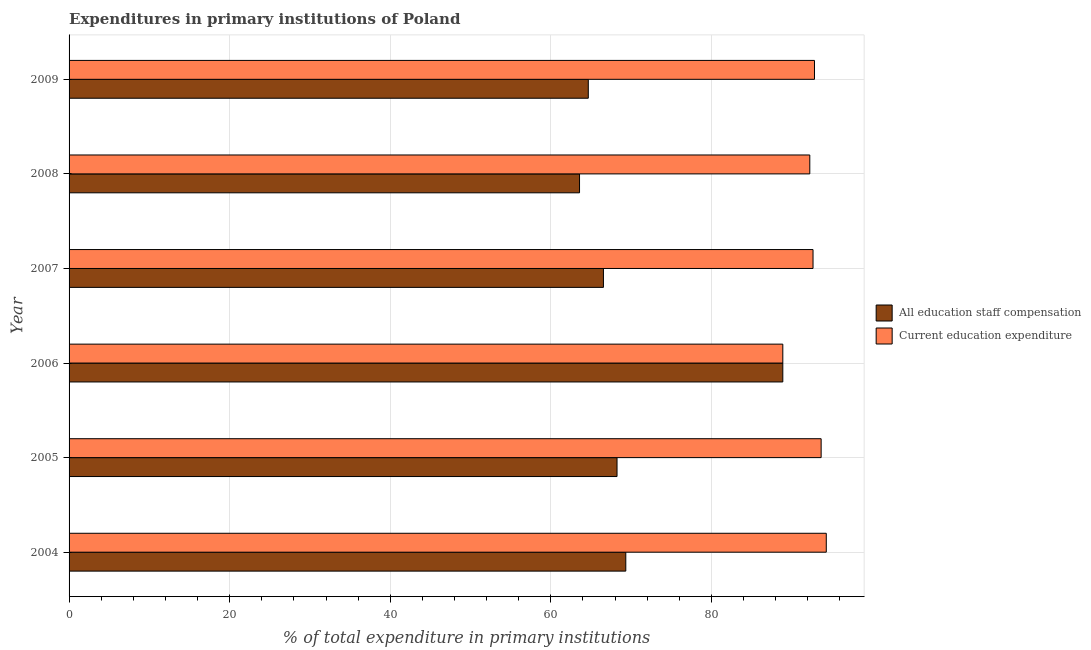How many groups of bars are there?
Ensure brevity in your answer.  6. How many bars are there on the 5th tick from the top?
Offer a terse response. 2. What is the expenditure in education in 2008?
Your answer should be very brief. 92.25. Across all years, what is the maximum expenditure in staff compensation?
Your response must be concise. 88.89. Across all years, what is the minimum expenditure in education?
Keep it short and to the point. 88.89. In which year was the expenditure in education maximum?
Provide a succinct answer. 2004. What is the total expenditure in education in the graph?
Provide a succinct answer. 554.62. What is the difference between the expenditure in education in 2007 and that in 2009?
Keep it short and to the point. -0.18. What is the difference between the expenditure in education in 2008 and the expenditure in staff compensation in 2007?
Offer a terse response. 25.7. What is the average expenditure in staff compensation per year?
Provide a succinct answer. 70.21. In the year 2009, what is the difference between the expenditure in staff compensation and expenditure in education?
Your answer should be compact. -28.17. What is the difference between the highest and the second highest expenditure in education?
Offer a terse response. 0.64. What is the difference between the highest and the lowest expenditure in education?
Your answer should be very brief. 5.42. What does the 1st bar from the top in 2004 represents?
Give a very brief answer. Current education expenditure. What does the 2nd bar from the bottom in 2007 represents?
Your answer should be very brief. Current education expenditure. How many bars are there?
Offer a terse response. 12. Are all the bars in the graph horizontal?
Offer a terse response. Yes. How many years are there in the graph?
Your answer should be compact. 6. Are the values on the major ticks of X-axis written in scientific E-notation?
Make the answer very short. No. Where does the legend appear in the graph?
Ensure brevity in your answer.  Center right. What is the title of the graph?
Your answer should be compact. Expenditures in primary institutions of Poland. What is the label or title of the X-axis?
Give a very brief answer. % of total expenditure in primary institutions. What is the % of total expenditure in primary institutions in All education staff compensation in 2004?
Ensure brevity in your answer.  69.34. What is the % of total expenditure in primary institutions of Current education expenditure in 2004?
Your answer should be compact. 94.31. What is the % of total expenditure in primary institutions in All education staff compensation in 2005?
Your answer should be compact. 68.25. What is the % of total expenditure in primary institutions in Current education expenditure in 2005?
Your answer should be compact. 93.67. What is the % of total expenditure in primary institutions of All education staff compensation in 2006?
Keep it short and to the point. 88.89. What is the % of total expenditure in primary institutions of Current education expenditure in 2006?
Your answer should be very brief. 88.89. What is the % of total expenditure in primary institutions of All education staff compensation in 2007?
Ensure brevity in your answer.  66.55. What is the % of total expenditure in primary institutions of Current education expenditure in 2007?
Keep it short and to the point. 92.66. What is the % of total expenditure in primary institutions of All education staff compensation in 2008?
Offer a very short reply. 63.57. What is the % of total expenditure in primary institutions in Current education expenditure in 2008?
Ensure brevity in your answer.  92.25. What is the % of total expenditure in primary institutions of All education staff compensation in 2009?
Make the answer very short. 64.67. What is the % of total expenditure in primary institutions of Current education expenditure in 2009?
Your response must be concise. 92.84. Across all years, what is the maximum % of total expenditure in primary institutions of All education staff compensation?
Your response must be concise. 88.89. Across all years, what is the maximum % of total expenditure in primary institutions in Current education expenditure?
Your response must be concise. 94.31. Across all years, what is the minimum % of total expenditure in primary institutions in All education staff compensation?
Your response must be concise. 63.57. Across all years, what is the minimum % of total expenditure in primary institutions in Current education expenditure?
Ensure brevity in your answer.  88.89. What is the total % of total expenditure in primary institutions in All education staff compensation in the graph?
Provide a short and direct response. 421.27. What is the total % of total expenditure in primary institutions of Current education expenditure in the graph?
Provide a succinct answer. 554.62. What is the difference between the % of total expenditure in primary institutions of All education staff compensation in 2004 and that in 2005?
Make the answer very short. 1.09. What is the difference between the % of total expenditure in primary institutions of Current education expenditure in 2004 and that in 2005?
Keep it short and to the point. 0.64. What is the difference between the % of total expenditure in primary institutions of All education staff compensation in 2004 and that in 2006?
Ensure brevity in your answer.  -19.56. What is the difference between the % of total expenditure in primary institutions of Current education expenditure in 2004 and that in 2006?
Offer a very short reply. 5.42. What is the difference between the % of total expenditure in primary institutions in All education staff compensation in 2004 and that in 2007?
Ensure brevity in your answer.  2.78. What is the difference between the % of total expenditure in primary institutions of Current education expenditure in 2004 and that in 2007?
Your answer should be very brief. 1.65. What is the difference between the % of total expenditure in primary institutions in All education staff compensation in 2004 and that in 2008?
Offer a very short reply. 5.76. What is the difference between the % of total expenditure in primary institutions in Current education expenditure in 2004 and that in 2008?
Keep it short and to the point. 2.05. What is the difference between the % of total expenditure in primary institutions in All education staff compensation in 2004 and that in 2009?
Make the answer very short. 4.67. What is the difference between the % of total expenditure in primary institutions in Current education expenditure in 2004 and that in 2009?
Your answer should be very brief. 1.47. What is the difference between the % of total expenditure in primary institutions in All education staff compensation in 2005 and that in 2006?
Your answer should be compact. -20.65. What is the difference between the % of total expenditure in primary institutions in Current education expenditure in 2005 and that in 2006?
Give a very brief answer. 4.78. What is the difference between the % of total expenditure in primary institutions of All education staff compensation in 2005 and that in 2007?
Your answer should be compact. 1.69. What is the difference between the % of total expenditure in primary institutions of Current education expenditure in 2005 and that in 2007?
Give a very brief answer. 1.01. What is the difference between the % of total expenditure in primary institutions of All education staff compensation in 2005 and that in 2008?
Offer a very short reply. 4.67. What is the difference between the % of total expenditure in primary institutions of Current education expenditure in 2005 and that in 2008?
Provide a succinct answer. 1.41. What is the difference between the % of total expenditure in primary institutions of All education staff compensation in 2005 and that in 2009?
Your answer should be very brief. 3.58. What is the difference between the % of total expenditure in primary institutions of Current education expenditure in 2005 and that in 2009?
Your response must be concise. 0.83. What is the difference between the % of total expenditure in primary institutions of All education staff compensation in 2006 and that in 2007?
Ensure brevity in your answer.  22.34. What is the difference between the % of total expenditure in primary institutions in Current education expenditure in 2006 and that in 2007?
Provide a short and direct response. -3.76. What is the difference between the % of total expenditure in primary institutions of All education staff compensation in 2006 and that in 2008?
Offer a very short reply. 25.32. What is the difference between the % of total expenditure in primary institutions in Current education expenditure in 2006 and that in 2008?
Provide a succinct answer. -3.36. What is the difference between the % of total expenditure in primary institutions of All education staff compensation in 2006 and that in 2009?
Your answer should be compact. 24.23. What is the difference between the % of total expenditure in primary institutions in Current education expenditure in 2006 and that in 2009?
Keep it short and to the point. -3.95. What is the difference between the % of total expenditure in primary institutions in All education staff compensation in 2007 and that in 2008?
Keep it short and to the point. 2.98. What is the difference between the % of total expenditure in primary institutions of Current education expenditure in 2007 and that in 2008?
Provide a short and direct response. 0.4. What is the difference between the % of total expenditure in primary institutions of All education staff compensation in 2007 and that in 2009?
Keep it short and to the point. 1.89. What is the difference between the % of total expenditure in primary institutions in Current education expenditure in 2007 and that in 2009?
Provide a short and direct response. -0.18. What is the difference between the % of total expenditure in primary institutions in All education staff compensation in 2008 and that in 2009?
Make the answer very short. -1.09. What is the difference between the % of total expenditure in primary institutions of Current education expenditure in 2008 and that in 2009?
Offer a very short reply. -0.58. What is the difference between the % of total expenditure in primary institutions in All education staff compensation in 2004 and the % of total expenditure in primary institutions in Current education expenditure in 2005?
Offer a terse response. -24.33. What is the difference between the % of total expenditure in primary institutions of All education staff compensation in 2004 and the % of total expenditure in primary institutions of Current education expenditure in 2006?
Your answer should be compact. -19.56. What is the difference between the % of total expenditure in primary institutions in All education staff compensation in 2004 and the % of total expenditure in primary institutions in Current education expenditure in 2007?
Ensure brevity in your answer.  -23.32. What is the difference between the % of total expenditure in primary institutions of All education staff compensation in 2004 and the % of total expenditure in primary institutions of Current education expenditure in 2008?
Make the answer very short. -22.92. What is the difference between the % of total expenditure in primary institutions of All education staff compensation in 2004 and the % of total expenditure in primary institutions of Current education expenditure in 2009?
Give a very brief answer. -23.5. What is the difference between the % of total expenditure in primary institutions of All education staff compensation in 2005 and the % of total expenditure in primary institutions of Current education expenditure in 2006?
Your answer should be compact. -20.65. What is the difference between the % of total expenditure in primary institutions of All education staff compensation in 2005 and the % of total expenditure in primary institutions of Current education expenditure in 2007?
Your response must be concise. -24.41. What is the difference between the % of total expenditure in primary institutions of All education staff compensation in 2005 and the % of total expenditure in primary institutions of Current education expenditure in 2008?
Make the answer very short. -24.01. What is the difference between the % of total expenditure in primary institutions of All education staff compensation in 2005 and the % of total expenditure in primary institutions of Current education expenditure in 2009?
Provide a succinct answer. -24.59. What is the difference between the % of total expenditure in primary institutions in All education staff compensation in 2006 and the % of total expenditure in primary institutions in Current education expenditure in 2007?
Offer a very short reply. -3.76. What is the difference between the % of total expenditure in primary institutions in All education staff compensation in 2006 and the % of total expenditure in primary institutions in Current education expenditure in 2008?
Provide a short and direct response. -3.36. What is the difference between the % of total expenditure in primary institutions in All education staff compensation in 2006 and the % of total expenditure in primary institutions in Current education expenditure in 2009?
Ensure brevity in your answer.  -3.95. What is the difference between the % of total expenditure in primary institutions in All education staff compensation in 2007 and the % of total expenditure in primary institutions in Current education expenditure in 2008?
Keep it short and to the point. -25.7. What is the difference between the % of total expenditure in primary institutions in All education staff compensation in 2007 and the % of total expenditure in primary institutions in Current education expenditure in 2009?
Your answer should be compact. -26.28. What is the difference between the % of total expenditure in primary institutions of All education staff compensation in 2008 and the % of total expenditure in primary institutions of Current education expenditure in 2009?
Provide a short and direct response. -29.26. What is the average % of total expenditure in primary institutions in All education staff compensation per year?
Your answer should be compact. 70.21. What is the average % of total expenditure in primary institutions of Current education expenditure per year?
Give a very brief answer. 92.44. In the year 2004, what is the difference between the % of total expenditure in primary institutions in All education staff compensation and % of total expenditure in primary institutions in Current education expenditure?
Your response must be concise. -24.97. In the year 2005, what is the difference between the % of total expenditure in primary institutions of All education staff compensation and % of total expenditure in primary institutions of Current education expenditure?
Your response must be concise. -25.42. In the year 2006, what is the difference between the % of total expenditure in primary institutions of All education staff compensation and % of total expenditure in primary institutions of Current education expenditure?
Keep it short and to the point. 0. In the year 2007, what is the difference between the % of total expenditure in primary institutions of All education staff compensation and % of total expenditure in primary institutions of Current education expenditure?
Give a very brief answer. -26.1. In the year 2008, what is the difference between the % of total expenditure in primary institutions in All education staff compensation and % of total expenditure in primary institutions in Current education expenditure?
Offer a terse response. -28.68. In the year 2009, what is the difference between the % of total expenditure in primary institutions in All education staff compensation and % of total expenditure in primary institutions in Current education expenditure?
Your answer should be very brief. -28.17. What is the ratio of the % of total expenditure in primary institutions of Current education expenditure in 2004 to that in 2005?
Offer a terse response. 1.01. What is the ratio of the % of total expenditure in primary institutions in All education staff compensation in 2004 to that in 2006?
Give a very brief answer. 0.78. What is the ratio of the % of total expenditure in primary institutions in Current education expenditure in 2004 to that in 2006?
Provide a short and direct response. 1.06. What is the ratio of the % of total expenditure in primary institutions in All education staff compensation in 2004 to that in 2007?
Keep it short and to the point. 1.04. What is the ratio of the % of total expenditure in primary institutions of Current education expenditure in 2004 to that in 2007?
Give a very brief answer. 1.02. What is the ratio of the % of total expenditure in primary institutions in All education staff compensation in 2004 to that in 2008?
Your answer should be very brief. 1.09. What is the ratio of the % of total expenditure in primary institutions in Current education expenditure in 2004 to that in 2008?
Make the answer very short. 1.02. What is the ratio of the % of total expenditure in primary institutions of All education staff compensation in 2004 to that in 2009?
Offer a very short reply. 1.07. What is the ratio of the % of total expenditure in primary institutions of Current education expenditure in 2004 to that in 2009?
Provide a short and direct response. 1.02. What is the ratio of the % of total expenditure in primary institutions of All education staff compensation in 2005 to that in 2006?
Provide a succinct answer. 0.77. What is the ratio of the % of total expenditure in primary institutions in Current education expenditure in 2005 to that in 2006?
Offer a terse response. 1.05. What is the ratio of the % of total expenditure in primary institutions in All education staff compensation in 2005 to that in 2007?
Your answer should be very brief. 1.03. What is the ratio of the % of total expenditure in primary institutions in Current education expenditure in 2005 to that in 2007?
Your response must be concise. 1.01. What is the ratio of the % of total expenditure in primary institutions in All education staff compensation in 2005 to that in 2008?
Provide a short and direct response. 1.07. What is the ratio of the % of total expenditure in primary institutions in Current education expenditure in 2005 to that in 2008?
Your answer should be very brief. 1.02. What is the ratio of the % of total expenditure in primary institutions of All education staff compensation in 2005 to that in 2009?
Your response must be concise. 1.06. What is the ratio of the % of total expenditure in primary institutions in Current education expenditure in 2005 to that in 2009?
Your answer should be very brief. 1.01. What is the ratio of the % of total expenditure in primary institutions in All education staff compensation in 2006 to that in 2007?
Your answer should be very brief. 1.34. What is the ratio of the % of total expenditure in primary institutions in Current education expenditure in 2006 to that in 2007?
Your response must be concise. 0.96. What is the ratio of the % of total expenditure in primary institutions in All education staff compensation in 2006 to that in 2008?
Your response must be concise. 1.4. What is the ratio of the % of total expenditure in primary institutions of Current education expenditure in 2006 to that in 2008?
Keep it short and to the point. 0.96. What is the ratio of the % of total expenditure in primary institutions of All education staff compensation in 2006 to that in 2009?
Keep it short and to the point. 1.37. What is the ratio of the % of total expenditure in primary institutions of Current education expenditure in 2006 to that in 2009?
Your answer should be compact. 0.96. What is the ratio of the % of total expenditure in primary institutions of All education staff compensation in 2007 to that in 2008?
Your answer should be very brief. 1.05. What is the ratio of the % of total expenditure in primary institutions in All education staff compensation in 2007 to that in 2009?
Your answer should be very brief. 1.03. What is the ratio of the % of total expenditure in primary institutions of Current education expenditure in 2007 to that in 2009?
Give a very brief answer. 1. What is the ratio of the % of total expenditure in primary institutions in All education staff compensation in 2008 to that in 2009?
Ensure brevity in your answer.  0.98. What is the difference between the highest and the second highest % of total expenditure in primary institutions in All education staff compensation?
Provide a short and direct response. 19.56. What is the difference between the highest and the second highest % of total expenditure in primary institutions in Current education expenditure?
Ensure brevity in your answer.  0.64. What is the difference between the highest and the lowest % of total expenditure in primary institutions of All education staff compensation?
Your response must be concise. 25.32. What is the difference between the highest and the lowest % of total expenditure in primary institutions of Current education expenditure?
Provide a short and direct response. 5.42. 